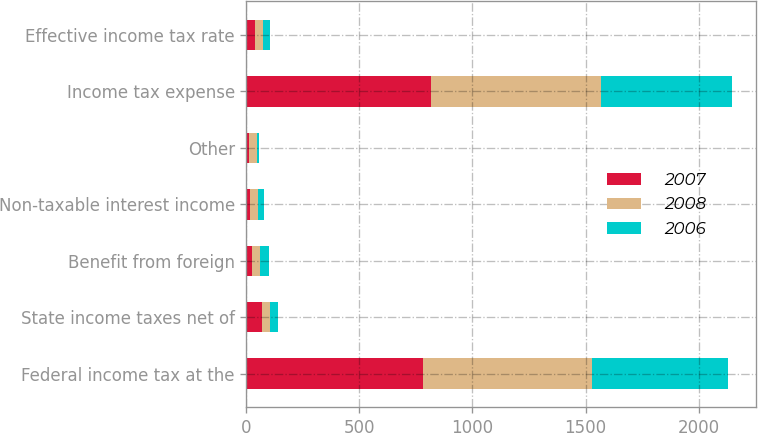Convert chart to OTSL. <chart><loc_0><loc_0><loc_500><loc_500><stacked_bar_chart><ecel><fcel>Federal income tax at the<fcel>State income taxes net of<fcel>Benefit from foreign<fcel>Non-taxable interest income<fcel>Other<fcel>Income tax expense<fcel>Effective income tax rate<nl><fcel>2007<fcel>780<fcel>67<fcel>25<fcel>17<fcel>10<fcel>815<fcel>36.6<nl><fcel>2008<fcel>747<fcel>38<fcel>36<fcel>34<fcel>37<fcel>752<fcel>35.3<nl><fcel>2006<fcel>603<fcel>34<fcel>37<fcel>28<fcel>9<fcel>581<fcel>33.7<nl></chart> 